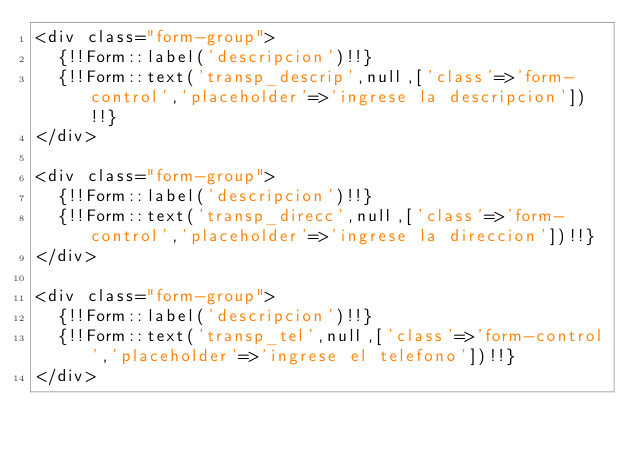<code> <loc_0><loc_0><loc_500><loc_500><_PHP_><div class="form-group">
	{!!Form::label('descripcion')!!}
	{!!Form::text('transp_descrip',null,['class'=>'form-control','placeholder'=>'ingrese la descripcion'])!!}
</div>

<div class="form-group">
	{!!Form::label('descripcion')!!}
	{!!Form::text('transp_direcc',null,['class'=>'form-control','placeholder'=>'ingrese la direccion'])!!}
</div>

<div class="form-group">
	{!!Form::label('descripcion')!!}
	{!!Form::text('transp_tel',null,['class'=>'form-control','placeholder'=>'ingrese el telefono'])!!}
</div></code> 